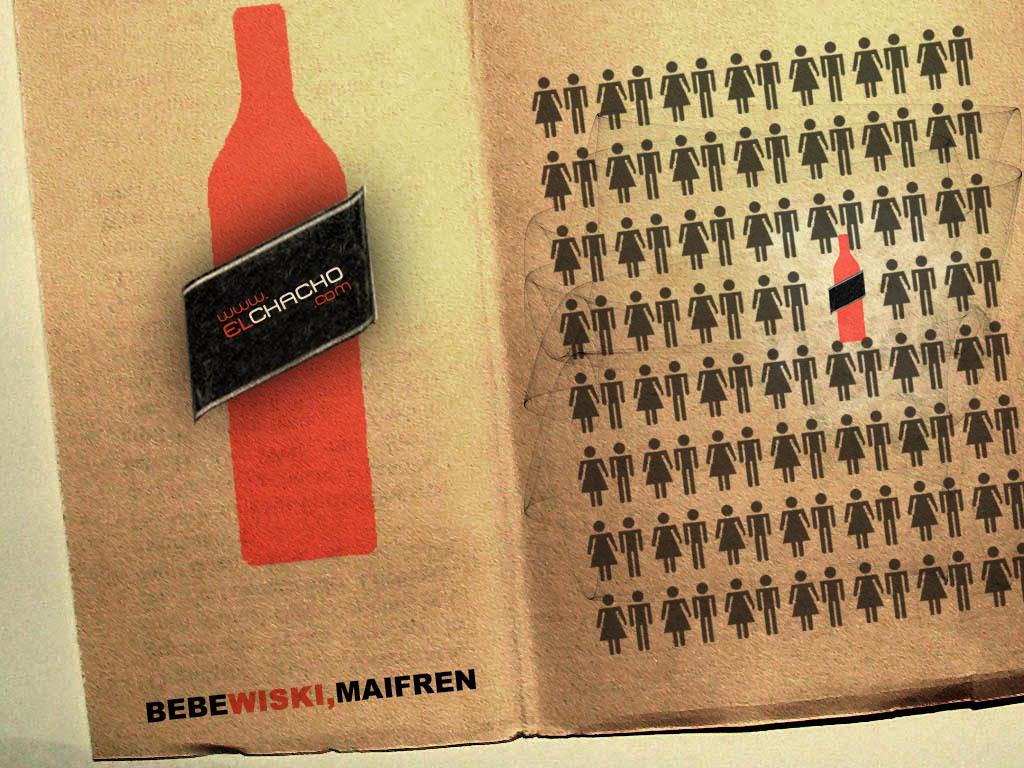What is the word in red text at the bottom of the page?
Provide a short and direct response. Wiski. 